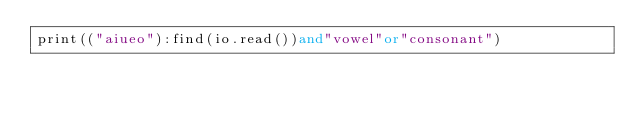<code> <loc_0><loc_0><loc_500><loc_500><_Lua_>print(("aiueo"):find(io.read())and"vowel"or"consonant")</code> 